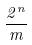Convert formula to latex. <formula><loc_0><loc_0><loc_500><loc_500>\frac { 2 ^ { n } } { m }</formula> 